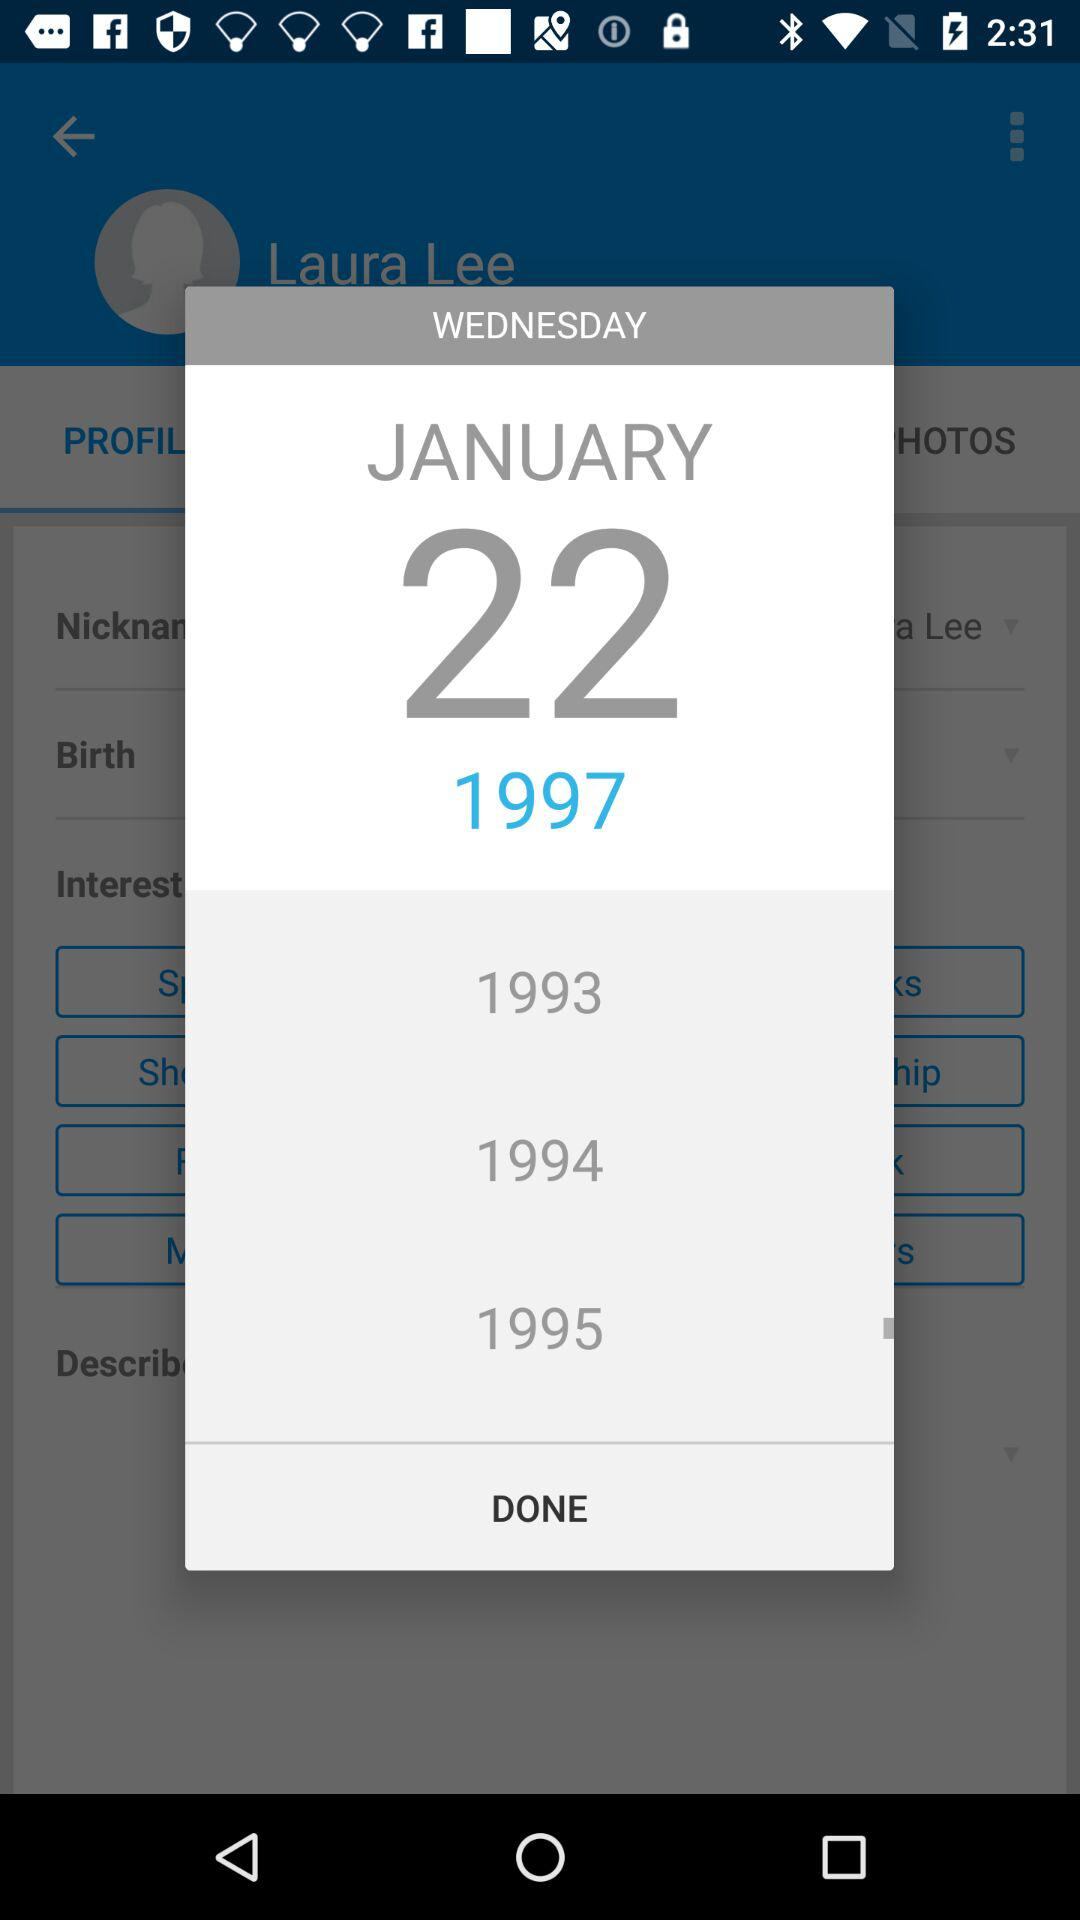What day is 22nd January 1997? The day is Wednesday. 